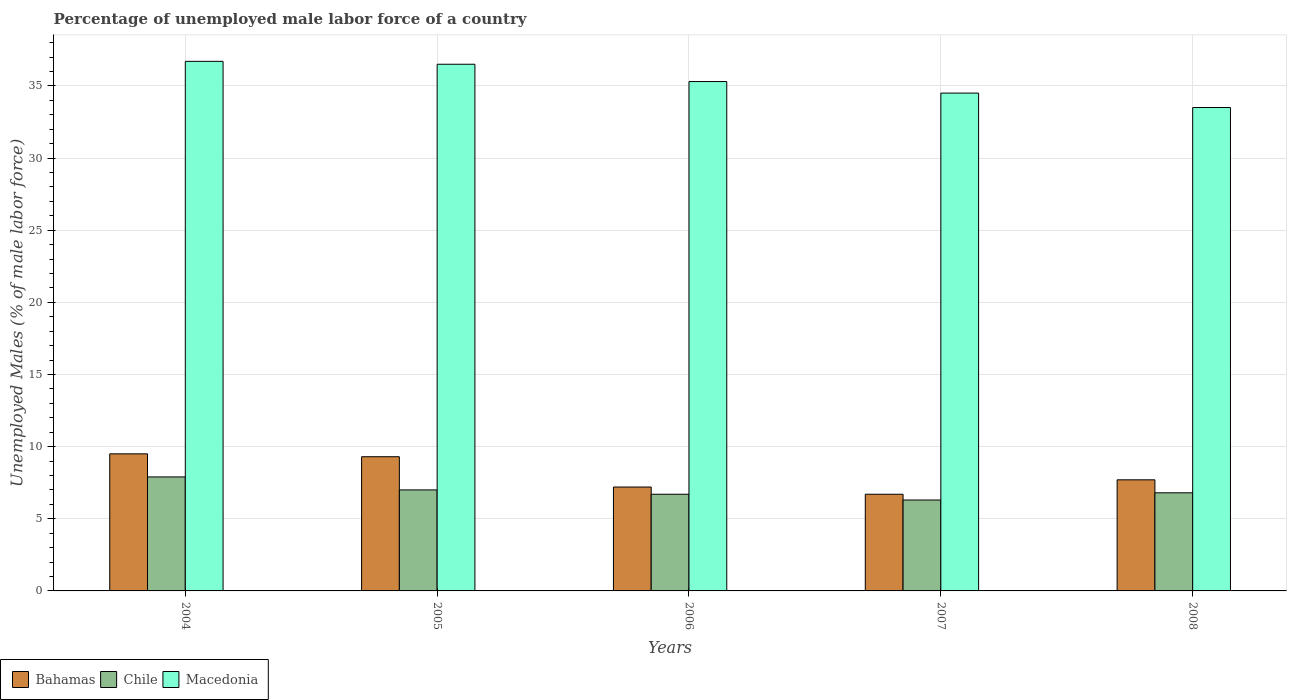How many different coloured bars are there?
Provide a succinct answer. 3. How many groups of bars are there?
Your answer should be very brief. 5. Are the number of bars per tick equal to the number of legend labels?
Give a very brief answer. Yes. How many bars are there on the 5th tick from the left?
Offer a terse response. 3. How many bars are there on the 3rd tick from the right?
Your answer should be compact. 3. In how many cases, is the number of bars for a given year not equal to the number of legend labels?
Ensure brevity in your answer.  0. What is the percentage of unemployed male labor force in Chile in 2005?
Your answer should be compact. 7. Across all years, what is the minimum percentage of unemployed male labor force in Chile?
Your response must be concise. 6.3. In which year was the percentage of unemployed male labor force in Macedonia minimum?
Your response must be concise. 2008. What is the total percentage of unemployed male labor force in Macedonia in the graph?
Make the answer very short. 176.5. What is the difference between the percentage of unemployed male labor force in Chile in 2007 and the percentage of unemployed male labor force in Macedonia in 2004?
Offer a very short reply. -30.4. What is the average percentage of unemployed male labor force in Bahamas per year?
Provide a short and direct response. 8.08. In the year 2008, what is the difference between the percentage of unemployed male labor force in Bahamas and percentage of unemployed male labor force in Chile?
Your response must be concise. 0.9. What is the ratio of the percentage of unemployed male labor force in Chile in 2005 to that in 2007?
Your answer should be compact. 1.11. Is the difference between the percentage of unemployed male labor force in Bahamas in 2006 and 2007 greater than the difference between the percentage of unemployed male labor force in Chile in 2006 and 2007?
Your answer should be very brief. Yes. What is the difference between the highest and the second highest percentage of unemployed male labor force in Bahamas?
Keep it short and to the point. 0.2. What is the difference between the highest and the lowest percentage of unemployed male labor force in Macedonia?
Your response must be concise. 3.2. What does the 3rd bar from the left in 2004 represents?
Provide a succinct answer. Macedonia. What does the 1st bar from the right in 2007 represents?
Your answer should be very brief. Macedonia. Are the values on the major ticks of Y-axis written in scientific E-notation?
Offer a terse response. No. Does the graph contain any zero values?
Offer a very short reply. No. Does the graph contain grids?
Your response must be concise. Yes. How many legend labels are there?
Provide a short and direct response. 3. What is the title of the graph?
Your answer should be compact. Percentage of unemployed male labor force of a country. Does "Antigua and Barbuda" appear as one of the legend labels in the graph?
Make the answer very short. No. What is the label or title of the X-axis?
Provide a succinct answer. Years. What is the label or title of the Y-axis?
Your answer should be very brief. Unemployed Males (% of male labor force). What is the Unemployed Males (% of male labor force) in Chile in 2004?
Make the answer very short. 7.9. What is the Unemployed Males (% of male labor force) in Macedonia in 2004?
Your answer should be very brief. 36.7. What is the Unemployed Males (% of male labor force) of Bahamas in 2005?
Your response must be concise. 9.3. What is the Unemployed Males (% of male labor force) in Chile in 2005?
Provide a short and direct response. 7. What is the Unemployed Males (% of male labor force) of Macedonia in 2005?
Keep it short and to the point. 36.5. What is the Unemployed Males (% of male labor force) in Bahamas in 2006?
Provide a succinct answer. 7.2. What is the Unemployed Males (% of male labor force) in Chile in 2006?
Offer a terse response. 6.7. What is the Unemployed Males (% of male labor force) in Macedonia in 2006?
Your response must be concise. 35.3. What is the Unemployed Males (% of male labor force) of Bahamas in 2007?
Make the answer very short. 6.7. What is the Unemployed Males (% of male labor force) of Chile in 2007?
Keep it short and to the point. 6.3. What is the Unemployed Males (% of male labor force) of Macedonia in 2007?
Offer a very short reply. 34.5. What is the Unemployed Males (% of male labor force) of Bahamas in 2008?
Your answer should be very brief. 7.7. What is the Unemployed Males (% of male labor force) in Chile in 2008?
Your response must be concise. 6.8. What is the Unemployed Males (% of male labor force) in Macedonia in 2008?
Your answer should be very brief. 33.5. Across all years, what is the maximum Unemployed Males (% of male labor force) in Bahamas?
Make the answer very short. 9.5. Across all years, what is the maximum Unemployed Males (% of male labor force) of Chile?
Offer a terse response. 7.9. Across all years, what is the maximum Unemployed Males (% of male labor force) of Macedonia?
Provide a short and direct response. 36.7. Across all years, what is the minimum Unemployed Males (% of male labor force) of Bahamas?
Offer a very short reply. 6.7. Across all years, what is the minimum Unemployed Males (% of male labor force) of Chile?
Offer a very short reply. 6.3. Across all years, what is the minimum Unemployed Males (% of male labor force) of Macedonia?
Your answer should be very brief. 33.5. What is the total Unemployed Males (% of male labor force) in Bahamas in the graph?
Give a very brief answer. 40.4. What is the total Unemployed Males (% of male labor force) of Chile in the graph?
Keep it short and to the point. 34.7. What is the total Unemployed Males (% of male labor force) of Macedonia in the graph?
Keep it short and to the point. 176.5. What is the difference between the Unemployed Males (% of male labor force) of Bahamas in 2004 and that in 2005?
Make the answer very short. 0.2. What is the difference between the Unemployed Males (% of male labor force) in Chile in 2004 and that in 2005?
Provide a short and direct response. 0.9. What is the difference between the Unemployed Males (% of male labor force) in Macedonia in 2004 and that in 2005?
Your answer should be compact. 0.2. What is the difference between the Unemployed Males (% of male labor force) in Bahamas in 2004 and that in 2007?
Ensure brevity in your answer.  2.8. What is the difference between the Unemployed Males (% of male labor force) of Bahamas in 2004 and that in 2008?
Give a very brief answer. 1.8. What is the difference between the Unemployed Males (% of male labor force) in Chile in 2004 and that in 2008?
Keep it short and to the point. 1.1. What is the difference between the Unemployed Males (% of male labor force) of Macedonia in 2004 and that in 2008?
Provide a short and direct response. 3.2. What is the difference between the Unemployed Males (% of male labor force) of Bahamas in 2005 and that in 2006?
Provide a short and direct response. 2.1. What is the difference between the Unemployed Males (% of male labor force) in Bahamas in 2005 and that in 2007?
Your response must be concise. 2.6. What is the difference between the Unemployed Males (% of male labor force) in Bahamas in 2005 and that in 2008?
Offer a very short reply. 1.6. What is the difference between the Unemployed Males (% of male labor force) in Chile in 2005 and that in 2008?
Offer a terse response. 0.2. What is the difference between the Unemployed Males (% of male labor force) in Chile in 2006 and that in 2007?
Offer a very short reply. 0.4. What is the difference between the Unemployed Males (% of male labor force) in Macedonia in 2006 and that in 2007?
Give a very brief answer. 0.8. What is the difference between the Unemployed Males (% of male labor force) of Bahamas in 2006 and that in 2008?
Your answer should be compact. -0.5. What is the difference between the Unemployed Males (% of male labor force) in Macedonia in 2006 and that in 2008?
Your response must be concise. 1.8. What is the difference between the Unemployed Males (% of male labor force) in Bahamas in 2004 and the Unemployed Males (% of male labor force) in Macedonia in 2005?
Ensure brevity in your answer.  -27. What is the difference between the Unemployed Males (% of male labor force) of Chile in 2004 and the Unemployed Males (% of male labor force) of Macedonia in 2005?
Ensure brevity in your answer.  -28.6. What is the difference between the Unemployed Males (% of male labor force) of Bahamas in 2004 and the Unemployed Males (% of male labor force) of Macedonia in 2006?
Your answer should be compact. -25.8. What is the difference between the Unemployed Males (% of male labor force) in Chile in 2004 and the Unemployed Males (% of male labor force) in Macedonia in 2006?
Your response must be concise. -27.4. What is the difference between the Unemployed Males (% of male labor force) in Chile in 2004 and the Unemployed Males (% of male labor force) in Macedonia in 2007?
Your answer should be very brief. -26.6. What is the difference between the Unemployed Males (% of male labor force) of Chile in 2004 and the Unemployed Males (% of male labor force) of Macedonia in 2008?
Your response must be concise. -25.6. What is the difference between the Unemployed Males (% of male labor force) in Chile in 2005 and the Unemployed Males (% of male labor force) in Macedonia in 2006?
Offer a very short reply. -28.3. What is the difference between the Unemployed Males (% of male labor force) of Bahamas in 2005 and the Unemployed Males (% of male labor force) of Chile in 2007?
Your answer should be compact. 3. What is the difference between the Unemployed Males (% of male labor force) of Bahamas in 2005 and the Unemployed Males (% of male labor force) of Macedonia in 2007?
Provide a succinct answer. -25.2. What is the difference between the Unemployed Males (% of male labor force) in Chile in 2005 and the Unemployed Males (% of male labor force) in Macedonia in 2007?
Ensure brevity in your answer.  -27.5. What is the difference between the Unemployed Males (% of male labor force) in Bahamas in 2005 and the Unemployed Males (% of male labor force) in Macedonia in 2008?
Your response must be concise. -24.2. What is the difference between the Unemployed Males (% of male labor force) in Chile in 2005 and the Unemployed Males (% of male labor force) in Macedonia in 2008?
Give a very brief answer. -26.5. What is the difference between the Unemployed Males (% of male labor force) of Bahamas in 2006 and the Unemployed Males (% of male labor force) of Macedonia in 2007?
Your answer should be compact. -27.3. What is the difference between the Unemployed Males (% of male labor force) in Chile in 2006 and the Unemployed Males (% of male labor force) in Macedonia in 2007?
Ensure brevity in your answer.  -27.8. What is the difference between the Unemployed Males (% of male labor force) of Bahamas in 2006 and the Unemployed Males (% of male labor force) of Chile in 2008?
Offer a terse response. 0.4. What is the difference between the Unemployed Males (% of male labor force) in Bahamas in 2006 and the Unemployed Males (% of male labor force) in Macedonia in 2008?
Your response must be concise. -26.3. What is the difference between the Unemployed Males (% of male labor force) in Chile in 2006 and the Unemployed Males (% of male labor force) in Macedonia in 2008?
Keep it short and to the point. -26.8. What is the difference between the Unemployed Males (% of male labor force) of Bahamas in 2007 and the Unemployed Males (% of male labor force) of Macedonia in 2008?
Offer a very short reply. -26.8. What is the difference between the Unemployed Males (% of male labor force) in Chile in 2007 and the Unemployed Males (% of male labor force) in Macedonia in 2008?
Provide a succinct answer. -27.2. What is the average Unemployed Males (% of male labor force) in Bahamas per year?
Your answer should be compact. 8.08. What is the average Unemployed Males (% of male labor force) of Chile per year?
Keep it short and to the point. 6.94. What is the average Unemployed Males (% of male labor force) in Macedonia per year?
Your response must be concise. 35.3. In the year 2004, what is the difference between the Unemployed Males (% of male labor force) of Bahamas and Unemployed Males (% of male labor force) of Macedonia?
Your answer should be compact. -27.2. In the year 2004, what is the difference between the Unemployed Males (% of male labor force) in Chile and Unemployed Males (% of male labor force) in Macedonia?
Keep it short and to the point. -28.8. In the year 2005, what is the difference between the Unemployed Males (% of male labor force) of Bahamas and Unemployed Males (% of male labor force) of Macedonia?
Offer a very short reply. -27.2. In the year 2005, what is the difference between the Unemployed Males (% of male labor force) in Chile and Unemployed Males (% of male labor force) in Macedonia?
Your answer should be compact. -29.5. In the year 2006, what is the difference between the Unemployed Males (% of male labor force) of Bahamas and Unemployed Males (% of male labor force) of Macedonia?
Ensure brevity in your answer.  -28.1. In the year 2006, what is the difference between the Unemployed Males (% of male labor force) in Chile and Unemployed Males (% of male labor force) in Macedonia?
Keep it short and to the point. -28.6. In the year 2007, what is the difference between the Unemployed Males (% of male labor force) in Bahamas and Unemployed Males (% of male labor force) in Chile?
Your answer should be compact. 0.4. In the year 2007, what is the difference between the Unemployed Males (% of male labor force) in Bahamas and Unemployed Males (% of male labor force) in Macedonia?
Your answer should be compact. -27.8. In the year 2007, what is the difference between the Unemployed Males (% of male labor force) of Chile and Unemployed Males (% of male labor force) of Macedonia?
Your response must be concise. -28.2. In the year 2008, what is the difference between the Unemployed Males (% of male labor force) in Bahamas and Unemployed Males (% of male labor force) in Macedonia?
Offer a terse response. -25.8. In the year 2008, what is the difference between the Unemployed Males (% of male labor force) in Chile and Unemployed Males (% of male labor force) in Macedonia?
Offer a terse response. -26.7. What is the ratio of the Unemployed Males (% of male labor force) in Bahamas in 2004 to that in 2005?
Ensure brevity in your answer.  1.02. What is the ratio of the Unemployed Males (% of male labor force) of Chile in 2004 to that in 2005?
Your answer should be very brief. 1.13. What is the ratio of the Unemployed Males (% of male labor force) in Bahamas in 2004 to that in 2006?
Provide a succinct answer. 1.32. What is the ratio of the Unemployed Males (% of male labor force) in Chile in 2004 to that in 2006?
Your answer should be very brief. 1.18. What is the ratio of the Unemployed Males (% of male labor force) of Macedonia in 2004 to that in 2006?
Give a very brief answer. 1.04. What is the ratio of the Unemployed Males (% of male labor force) in Bahamas in 2004 to that in 2007?
Provide a succinct answer. 1.42. What is the ratio of the Unemployed Males (% of male labor force) in Chile in 2004 to that in 2007?
Offer a very short reply. 1.25. What is the ratio of the Unemployed Males (% of male labor force) in Macedonia in 2004 to that in 2007?
Your answer should be compact. 1.06. What is the ratio of the Unemployed Males (% of male labor force) in Bahamas in 2004 to that in 2008?
Your answer should be compact. 1.23. What is the ratio of the Unemployed Males (% of male labor force) in Chile in 2004 to that in 2008?
Ensure brevity in your answer.  1.16. What is the ratio of the Unemployed Males (% of male labor force) in Macedonia in 2004 to that in 2008?
Offer a very short reply. 1.1. What is the ratio of the Unemployed Males (% of male labor force) in Bahamas in 2005 to that in 2006?
Ensure brevity in your answer.  1.29. What is the ratio of the Unemployed Males (% of male labor force) of Chile in 2005 to that in 2006?
Provide a short and direct response. 1.04. What is the ratio of the Unemployed Males (% of male labor force) in Macedonia in 2005 to that in 2006?
Offer a very short reply. 1.03. What is the ratio of the Unemployed Males (% of male labor force) of Bahamas in 2005 to that in 2007?
Make the answer very short. 1.39. What is the ratio of the Unemployed Males (% of male labor force) in Chile in 2005 to that in 2007?
Offer a very short reply. 1.11. What is the ratio of the Unemployed Males (% of male labor force) of Macedonia in 2005 to that in 2007?
Your answer should be very brief. 1.06. What is the ratio of the Unemployed Males (% of male labor force) in Bahamas in 2005 to that in 2008?
Offer a very short reply. 1.21. What is the ratio of the Unemployed Males (% of male labor force) in Chile in 2005 to that in 2008?
Make the answer very short. 1.03. What is the ratio of the Unemployed Males (% of male labor force) of Macedonia in 2005 to that in 2008?
Make the answer very short. 1.09. What is the ratio of the Unemployed Males (% of male labor force) in Bahamas in 2006 to that in 2007?
Offer a terse response. 1.07. What is the ratio of the Unemployed Males (% of male labor force) in Chile in 2006 to that in 2007?
Your answer should be very brief. 1.06. What is the ratio of the Unemployed Males (% of male labor force) in Macedonia in 2006 to that in 2007?
Your answer should be compact. 1.02. What is the ratio of the Unemployed Males (% of male labor force) in Bahamas in 2006 to that in 2008?
Your answer should be very brief. 0.94. What is the ratio of the Unemployed Males (% of male labor force) of Macedonia in 2006 to that in 2008?
Ensure brevity in your answer.  1.05. What is the ratio of the Unemployed Males (% of male labor force) in Bahamas in 2007 to that in 2008?
Keep it short and to the point. 0.87. What is the ratio of the Unemployed Males (% of male labor force) in Chile in 2007 to that in 2008?
Offer a very short reply. 0.93. What is the ratio of the Unemployed Males (% of male labor force) in Macedonia in 2007 to that in 2008?
Your answer should be compact. 1.03. What is the difference between the highest and the second highest Unemployed Males (% of male labor force) of Macedonia?
Offer a very short reply. 0.2. What is the difference between the highest and the lowest Unemployed Males (% of male labor force) in Bahamas?
Keep it short and to the point. 2.8. What is the difference between the highest and the lowest Unemployed Males (% of male labor force) in Chile?
Provide a succinct answer. 1.6. 